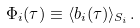<formula> <loc_0><loc_0><loc_500><loc_500>\Phi _ { i } ( \tau ) \equiv \langle b _ { i } ( \tau ) \rangle _ { S _ { i } } .</formula> 